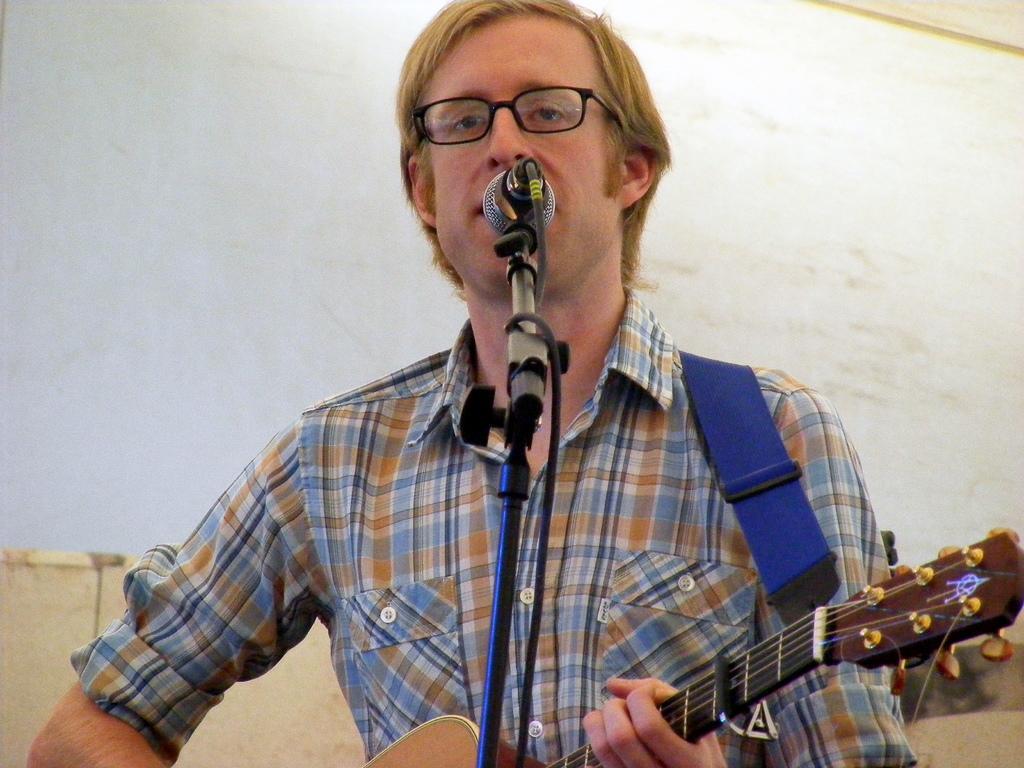In one or two sentences, can you explain what this image depicts? In this image i can see a man wearing glasses and shirt holding a guitar. I can see a microphone in front of him. In the background i can see a wall. 